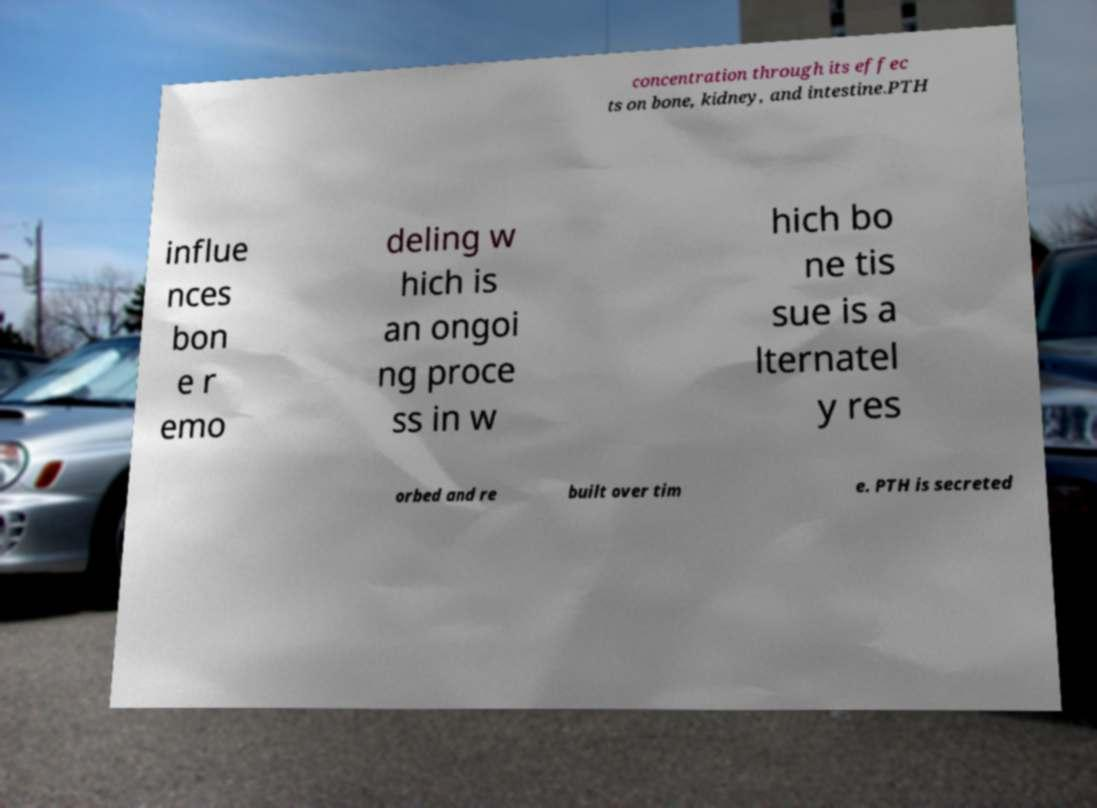There's text embedded in this image that I need extracted. Can you transcribe it verbatim? concentration through its effec ts on bone, kidney, and intestine.PTH influe nces bon e r emo deling w hich is an ongoi ng proce ss in w hich bo ne tis sue is a lternatel y res orbed and re built over tim e. PTH is secreted 